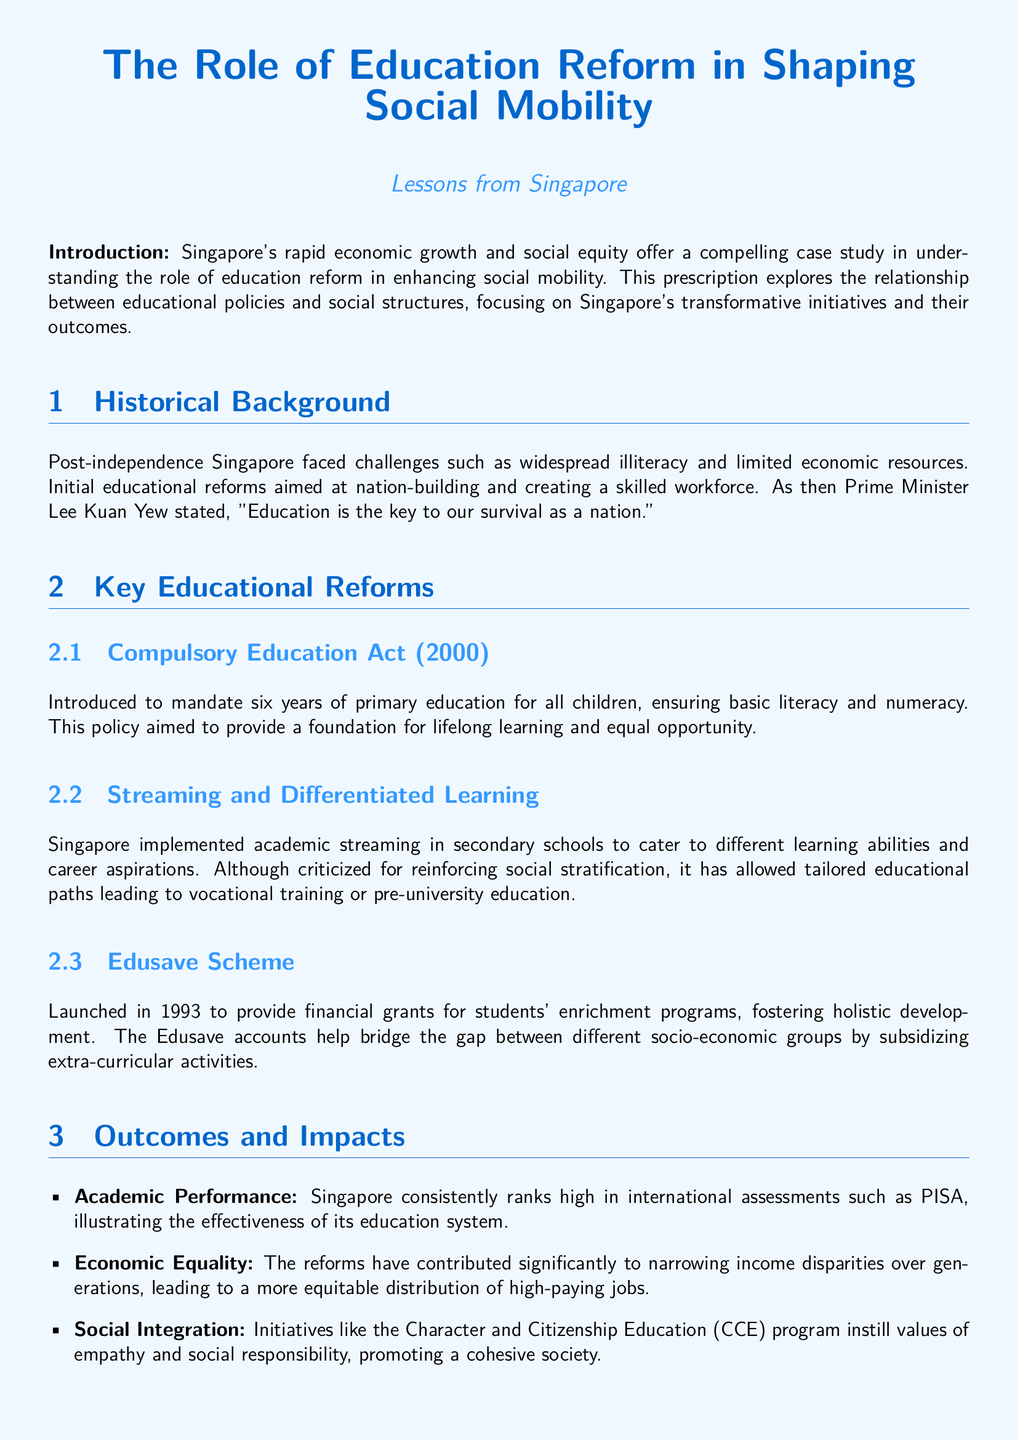What is the title of the document? The title of the document is found at the top and summarizes the main theme, focusing on education reform and social mobility.
Answer: The Role of Education Reform in Shaping Social Mobility When was the Compulsory Education Act introduced? The document specifies the year when the Compulsory Education Act was introduced, which established mandatory primary education.
Answer: 2000 What initiative was launched in 1993 to provide financial grants for students? The document mentions a specific program designed to support students' educational activities through financial assistance.
Answer: Edusave Scheme Which educational program promotes values of empathy and social responsibility? This question pertains to a specific program aimed at enhancing social cohesion within Singapore's diverse society.
Answer: Character and Citizenship Education (CCE) What is a notable achievement of Singapore's education system in international assessments? The document highlights a specific performance score that indicates the success of the education system on a global level.
Answer: High rankings in PISA What key outcome has been attributed to the educational reforms in terms of economic disparity? This question focuses on the effectiveness of educational policies in addressing income equality within the country.
Answer: Narrowing income disparities What approach should educational policies take according to the lessons learned from Singapore? The document suggests a specific quality that these policies must possess to remain effective and relevant to societal changes.
Answer: Dynamic and adaptive 